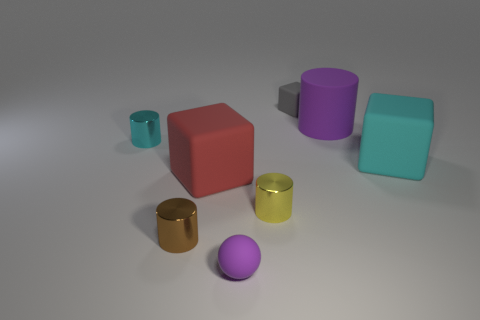There is a purple object in front of the brown object; does it have the same shape as the cyan matte thing?
Keep it short and to the point. No. There is a large thing behind the large cyan block; what color is it?
Offer a very short reply. Purple. How many spheres are either brown things or tiny yellow things?
Provide a short and direct response. 0. What is the size of the rubber block that is behind the cyan object in front of the cyan cylinder?
Your response must be concise. Small. Is the color of the small rubber ball the same as the cylinder that is right of the tiny yellow thing?
Your answer should be very brief. Yes. There is a large cyan matte thing; what number of big purple rubber cylinders are in front of it?
Offer a terse response. 0. Is the number of brown rubber balls less than the number of small gray matte blocks?
Offer a very short reply. Yes. There is a rubber object that is on the left side of the yellow shiny object and behind the rubber sphere; what is its size?
Your answer should be compact. Large. Does the shiny object that is to the right of the red matte cube have the same color as the rubber cylinder?
Offer a very short reply. No. Are there fewer big cyan blocks in front of the yellow cylinder than small gray rubber spheres?
Offer a very short reply. No. 